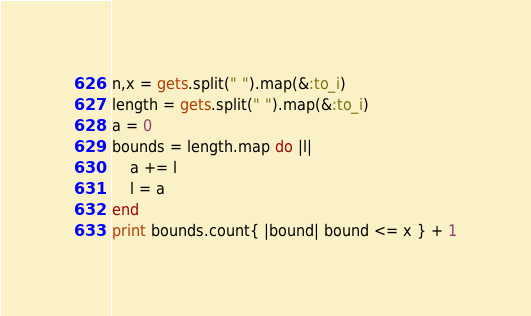<code> <loc_0><loc_0><loc_500><loc_500><_Ruby_>n,x = gets.split(" ").map(&:to_i)
length = gets.split(" ").map(&:to_i)
a = 0
bounds = length.map do |l|
    a += l
    l = a
end
print bounds.count{ |bound| bound <= x } + 1</code> 